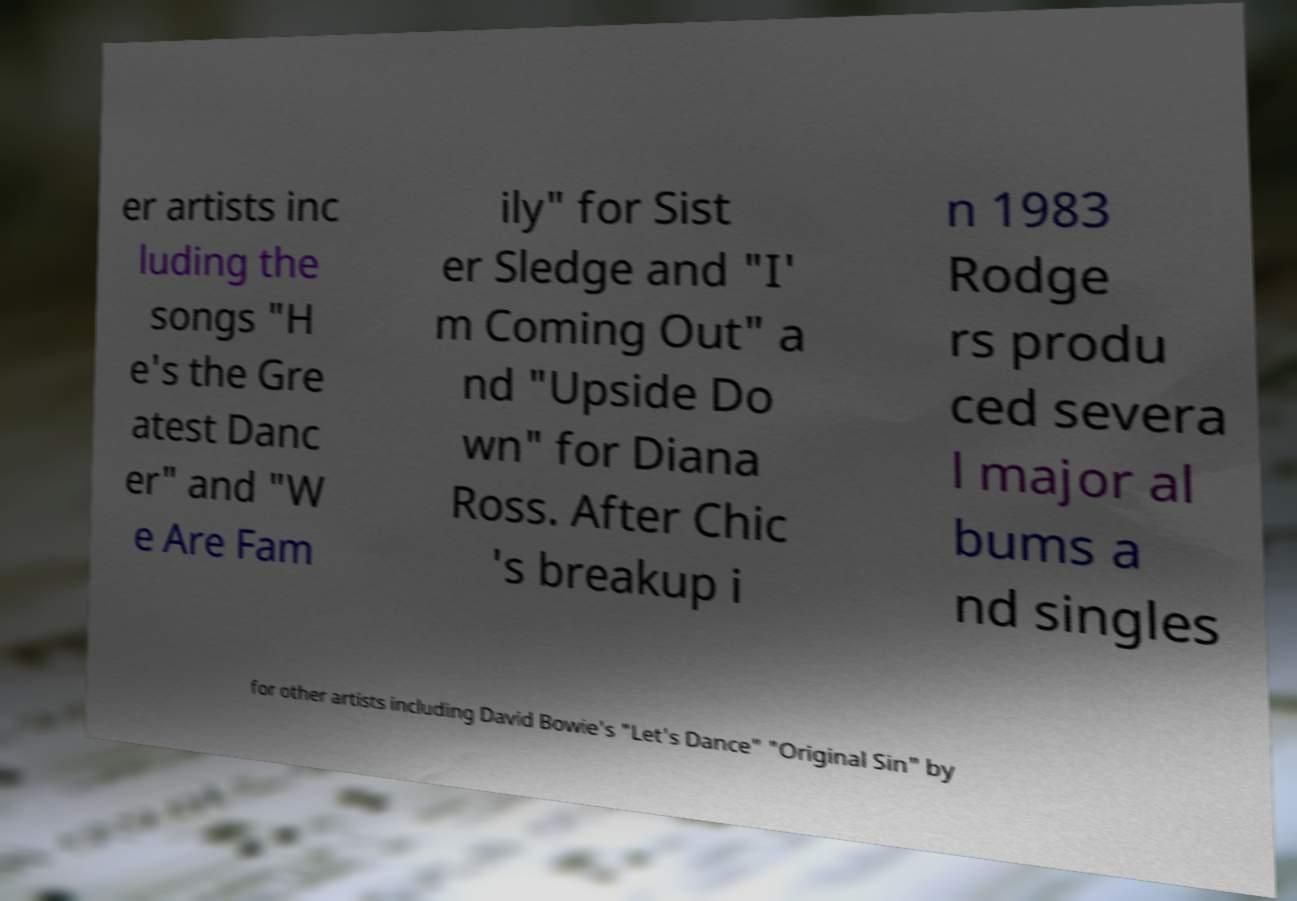Can you accurately transcribe the text from the provided image for me? er artists inc luding the songs "H e's the Gre atest Danc er" and "W e Are Fam ily" for Sist er Sledge and "I' m Coming Out" a nd "Upside Do wn" for Diana Ross. After Chic 's breakup i n 1983 Rodge rs produ ced severa l major al bums a nd singles for other artists including David Bowie's "Let's Dance" "Original Sin" by 